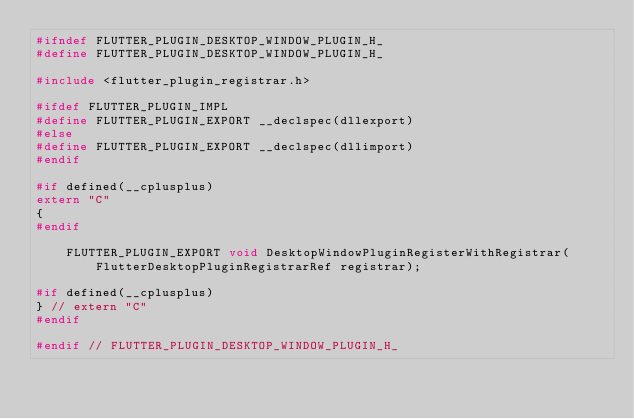Convert code to text. <code><loc_0><loc_0><loc_500><loc_500><_C_>#ifndef FLUTTER_PLUGIN_DESKTOP_WINDOW_PLUGIN_H_
#define FLUTTER_PLUGIN_DESKTOP_WINDOW_PLUGIN_H_

#include <flutter_plugin_registrar.h>

#ifdef FLUTTER_PLUGIN_IMPL
#define FLUTTER_PLUGIN_EXPORT __declspec(dllexport)
#else
#define FLUTTER_PLUGIN_EXPORT __declspec(dllimport)
#endif

#if defined(__cplusplus)
extern "C"
{
#endif

    FLUTTER_PLUGIN_EXPORT void DesktopWindowPluginRegisterWithRegistrar(
        FlutterDesktopPluginRegistrarRef registrar);

#if defined(__cplusplus)
} // extern "C"
#endif

#endif // FLUTTER_PLUGIN_DESKTOP_WINDOW_PLUGIN_H_
</code> 